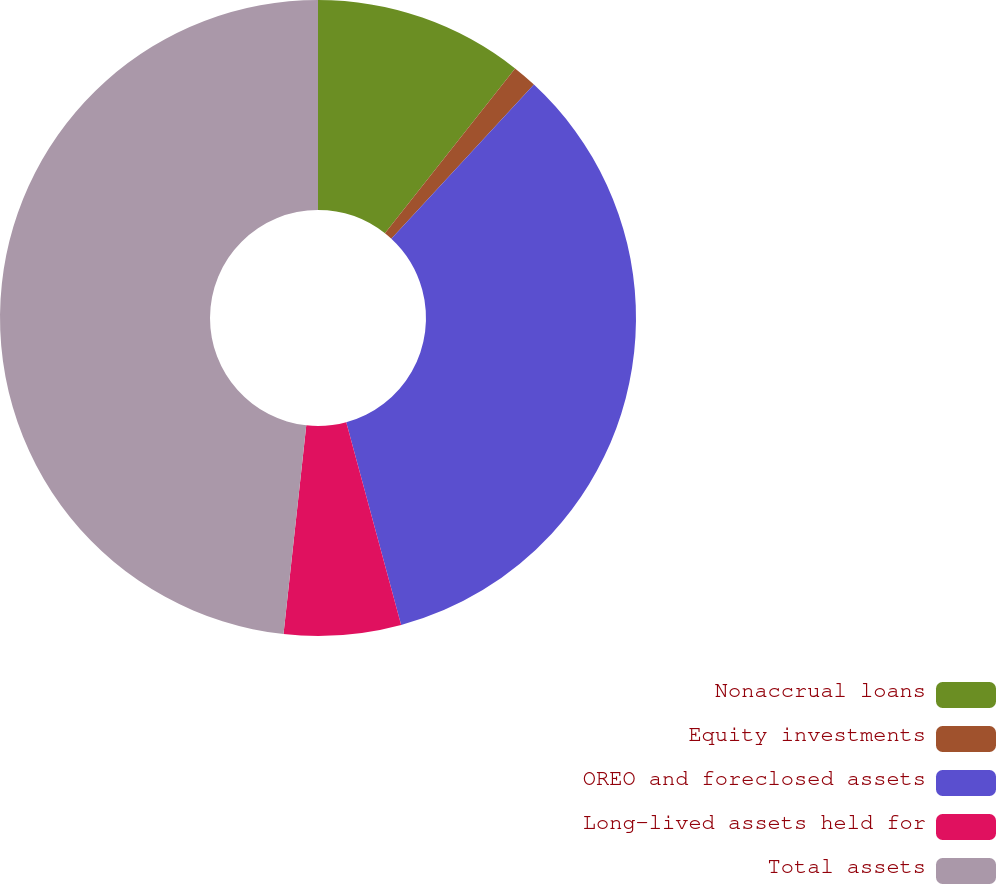<chart> <loc_0><loc_0><loc_500><loc_500><pie_chart><fcel>Nonaccrual loans<fcel>Equity investments<fcel>OREO and foreclosed assets<fcel>Long-lived assets held for<fcel>Total assets<nl><fcel>10.64%<fcel>1.24%<fcel>33.91%<fcel>5.94%<fcel>48.27%<nl></chart> 